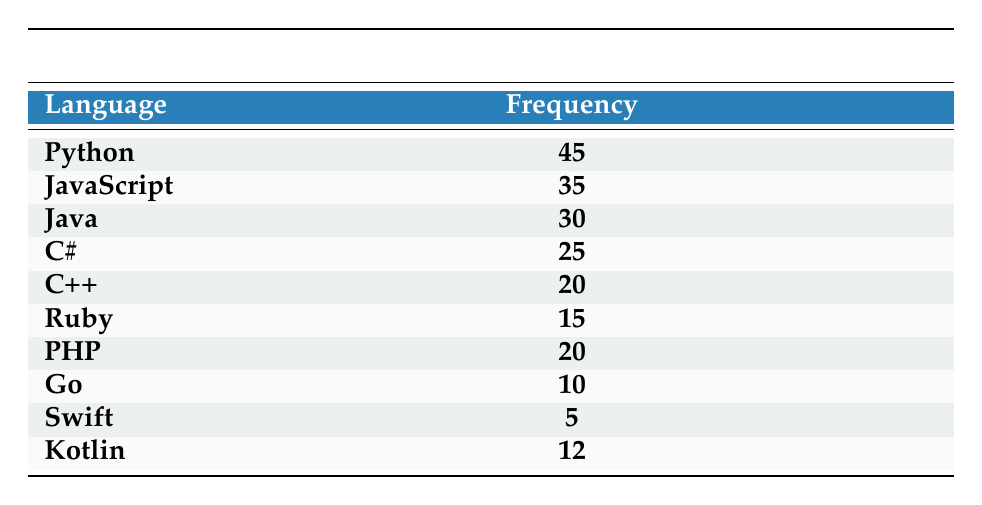What is the frequency of Python? The table lists Python with a frequency of 45.
Answer: 45 Which programming language has the lowest frequency? From the table, Swift has the lowest frequency at 5.
Answer: Swift What is the total frequency of languages C#, C++, and PHP combined? The frequencies are: C# (25), C++ (20), and PHP (20). Adding these gives 25 + 20 + 20 = 65.
Answer: 65 Is Ruby more frequently known than Go? Ruby has a frequency of 15 and Go has a frequency of 10. Since 15 is greater than 10, the statement is true.
Answer: Yes What is the average frequency of the programming languages listed? To find the average, sum all frequencies (45 + 35 + 30 + 25 + 20 + 15 + 20 + 10 + 5 + 12 =  212) and divide by the number of languages (10). So, 212 / 10 = 21.2.
Answer: 21.2 Which programming languages have a frequency of 20 or more? The languages with a frequency of 20 or more are Python (45), JavaScript (35), Java (30), C# (25), C++ (20), and PHP (20). Counting these we get 6 languages.
Answer: 6 If you compare Kotlin and Ruby, which one is known by more IT professionals? Kotlin has a frequency of 12 while Ruby has a frequency of 15. Since 15 is greater than 12, Ruby is known by more IT professionals.
Answer: Ruby What is the difference in frequency between Java and JavaScript? Java has a frequency of 30 and JavaScript has a frequency of 35. The difference is calculated as 35 - 30 = 5.
Answer: 5 Is the frequency of Go greater than or equal to the frequency of Swift? Go has a frequency of 10 and Swift has a frequency of 5. Since 10 is greater than 5, the statement is true.
Answer: Yes 